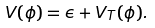<formula> <loc_0><loc_0><loc_500><loc_500>V ( \phi ) = \epsilon + V _ { T } ( \phi ) .</formula> 